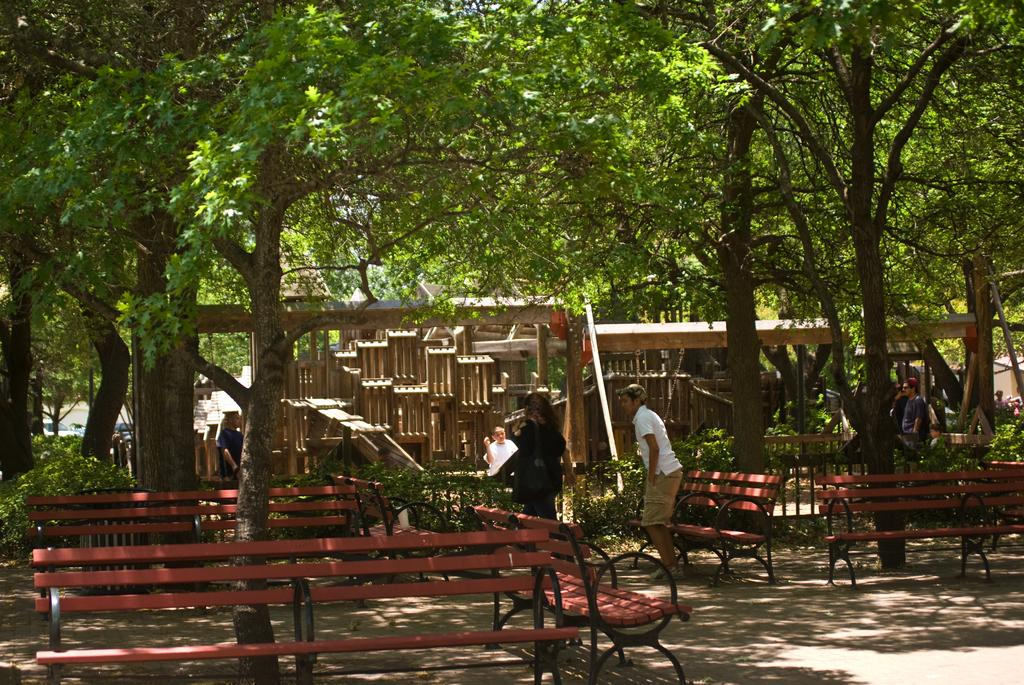What type of location is depicted in the image? The image appears to be a garden. What type of seating is available in the garden? There are benches present in the garden. Can you describe the people in the image? A man is standing in the image, and a woman is moving. What kind of decorative object can be seen in the garden? There is wooden art in the image. What type of reaction can be seen from the twig in the image? There is no twig present in the image. 